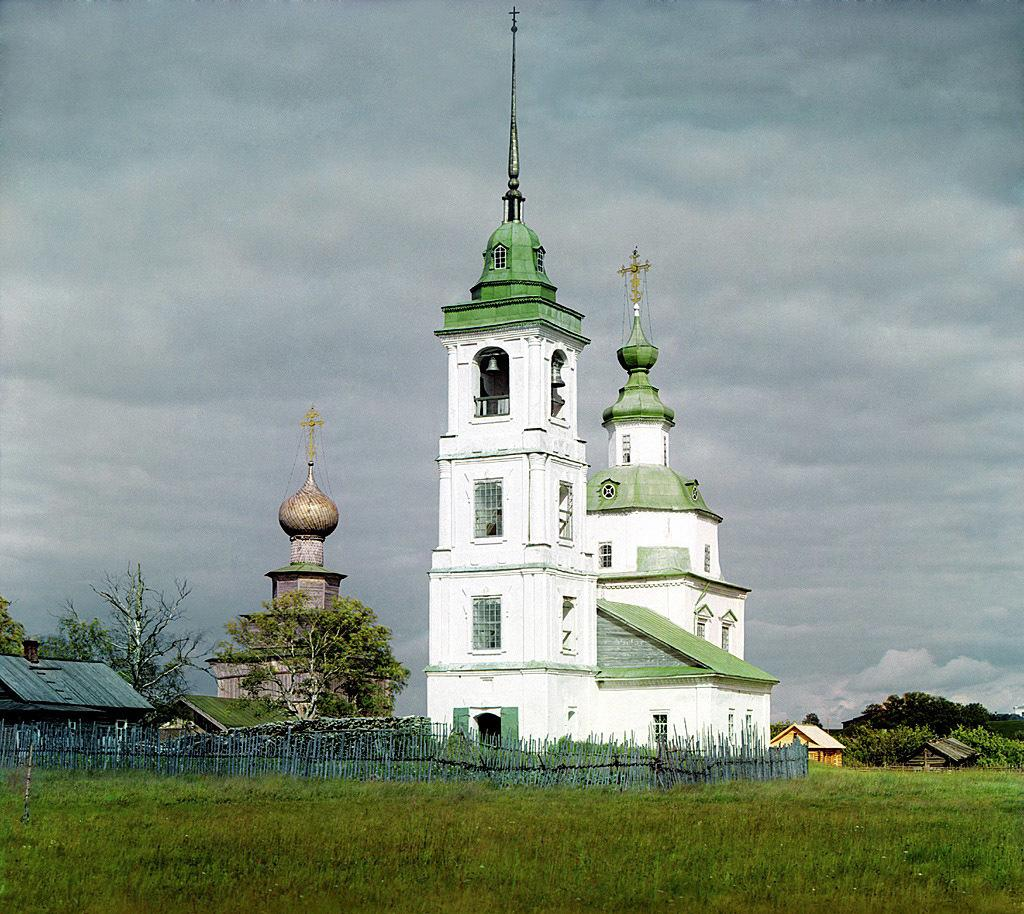What type of barrier can be seen in the image? There is a fence in the image. What type of vegetation is present in the image? There is grass in the image. What type of structures are visible in the image? There are houses and buildings in the image. What type of natural elements can be seen in the image? There are trees in the image. What is the condition of the sky in the image? The sky is cloudy in the image. How much does the weight of the bead affect the overall appearance of the image? There is no bead present in the image, so its weight cannot affect the appearance of the image. Can you see any steam coming from the houses or buildings in the image? There is no steam visible in the image; it features a fence, grass, houses, buildings, trees, and a cloudy sky. 